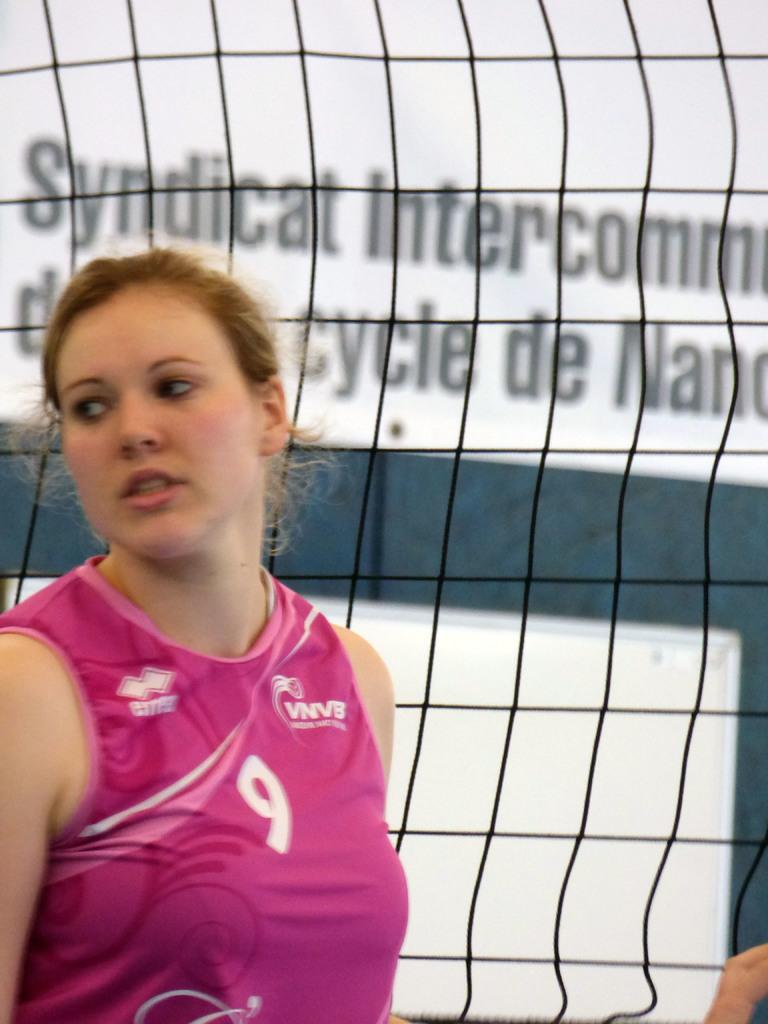<image>
Share a concise interpretation of the image provided. A young woman's pink shirt has the acronym VNVB on the front near a number 9. 